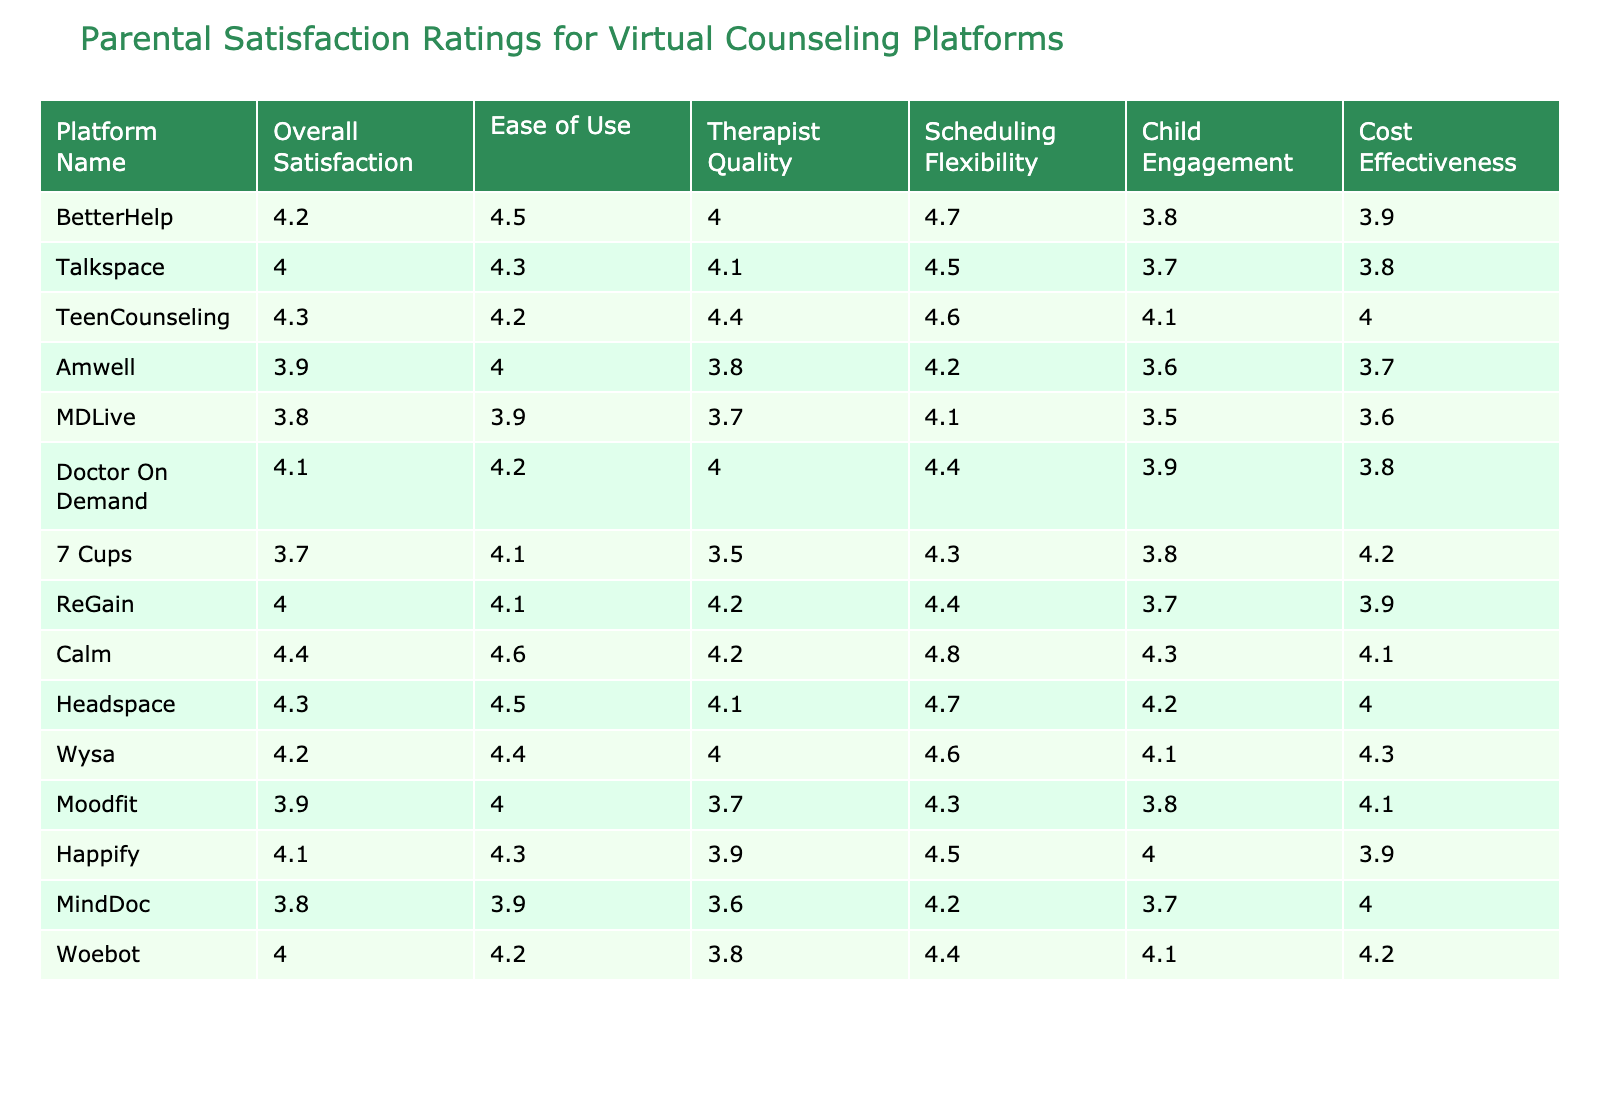What is the overall satisfaction rating for BetterHelp? The table shows that the overall satisfaction rating for BetterHelp is listed under the "Overall Satisfaction" column, which is 4.2.
Answer: 4.2 Which platform has the highest ease of use rating? Looking at the "Ease of Use" column, the highest rating is 4.6, attributed to Calm.
Answer: Calm What rating does Talkspace receive for therapist quality? The "Therapist Quality" rating for Talkspace is found in the corresponding row, and it is 4.1.
Answer: 4.1 Which platform is the most cost-effective based on the ratings provided? The "Cost Effectiveness" ratings show that 7 Cups has the highest rating of 4.2, making it the most cost-effective option.
Answer: 7 Cups What is the average scheduling flexibility rating for all platforms? To find the average, I sum the "Scheduling Flexibility" ratings (4.7 + 4.5 + 4.6 + 4.2 + 4.1 + 4.4 + 4.3 + 4.4 + 4.8 + 4.7 + 4.6 + 4.5 + 4.3 + 4.4) = 61.1 and there are 14 platforms, so the average is 61.1 / 14 = 4.36.
Answer: 4.36 Is it true that MDLive has an overall satisfaction rating lower than 4.0? The overall satisfaction rating for MDLive displayed in the table is 3.8, which is indeed lower than 4.0.
Answer: True Which platform shows the greatest difference between child engagement and therapist quality ratings? First, we calculate the differences: BetterHelp (4.2 - 3.8 = 0.4), Talkspace (4.1 - 3.7 = 0.4), TeenCounseling (4.4 - 4.1 = 0.3), Amwell (3.8 - 3.6 = 0.2), MDLive (3.7 - 3.5 = 0.2), Doctor On Demand (4.0 - 3.9 = 0.1), 7 Cups (3.5 - 3.8 = -0.3), ReGain (4.2 - 3.7 = 0.5), Calm (4.2 - 4.3 = -0.1), Headspace (4.1 - 4.2 = -0.1), Wysa (4.0 - 4.1 = -0.1), Moodfit (3.7 - 3.8 = -0.1), Happify (3.9 - 4.0 = -0.1), Woebot (3.8 - 4.1 = -0.3). The largest difference is 0.5 for ReGain.
Answer: ReGain What is the total of all ease of use ratings? Adding up the "Ease of Use" ratings yields: 4.5 + 4.3 + 4.2 + 4.0 + 3.9 + 4.2 + 4.1 + 4.1 + 4.6 + 4.5 + 4.4 + 4.3 + 4.0 + 4.2 = 57.3.
Answer: 57.3 Which platform has both high scheduling flexibility and child engagement? High scheduling flexibility means a rating above 4.4 and high child engagement means a rating above 4.0. Both Calm (4.8, 4.3) and TeenCounseling (4.6, 4.1) meet this criterion.
Answer: Calm and TeenCounseling Is the average overall satisfaction rating across all platforms above 4.0? The sum of the overall satisfaction ratings is (4.2 + 4.0 + 4.3 + 3.9 + 3.8 + 4.1 + 3.7 + 4.0 + 4.4 + 4.3 + 4.2 + 3.9 + 4.1 + 4.0) = 58.2, and there are 14 platforms, so the average is 58.2 / 14 = 4.16, which is above 4.0.
Answer: True 